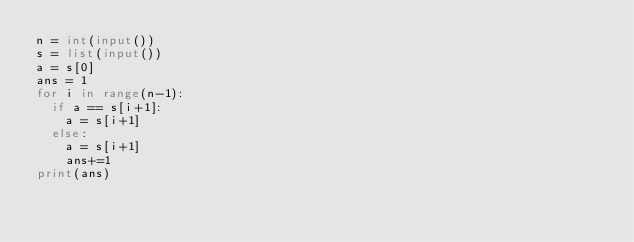Convert code to text. <code><loc_0><loc_0><loc_500><loc_500><_Python_>n = int(input())
s = list(input())
a = s[0]
ans = 1
for i in range(n-1):
  if a == s[i+1]:
    a = s[i+1]
  else:
    a = s[i+1]
    ans+=1
print(ans)</code> 